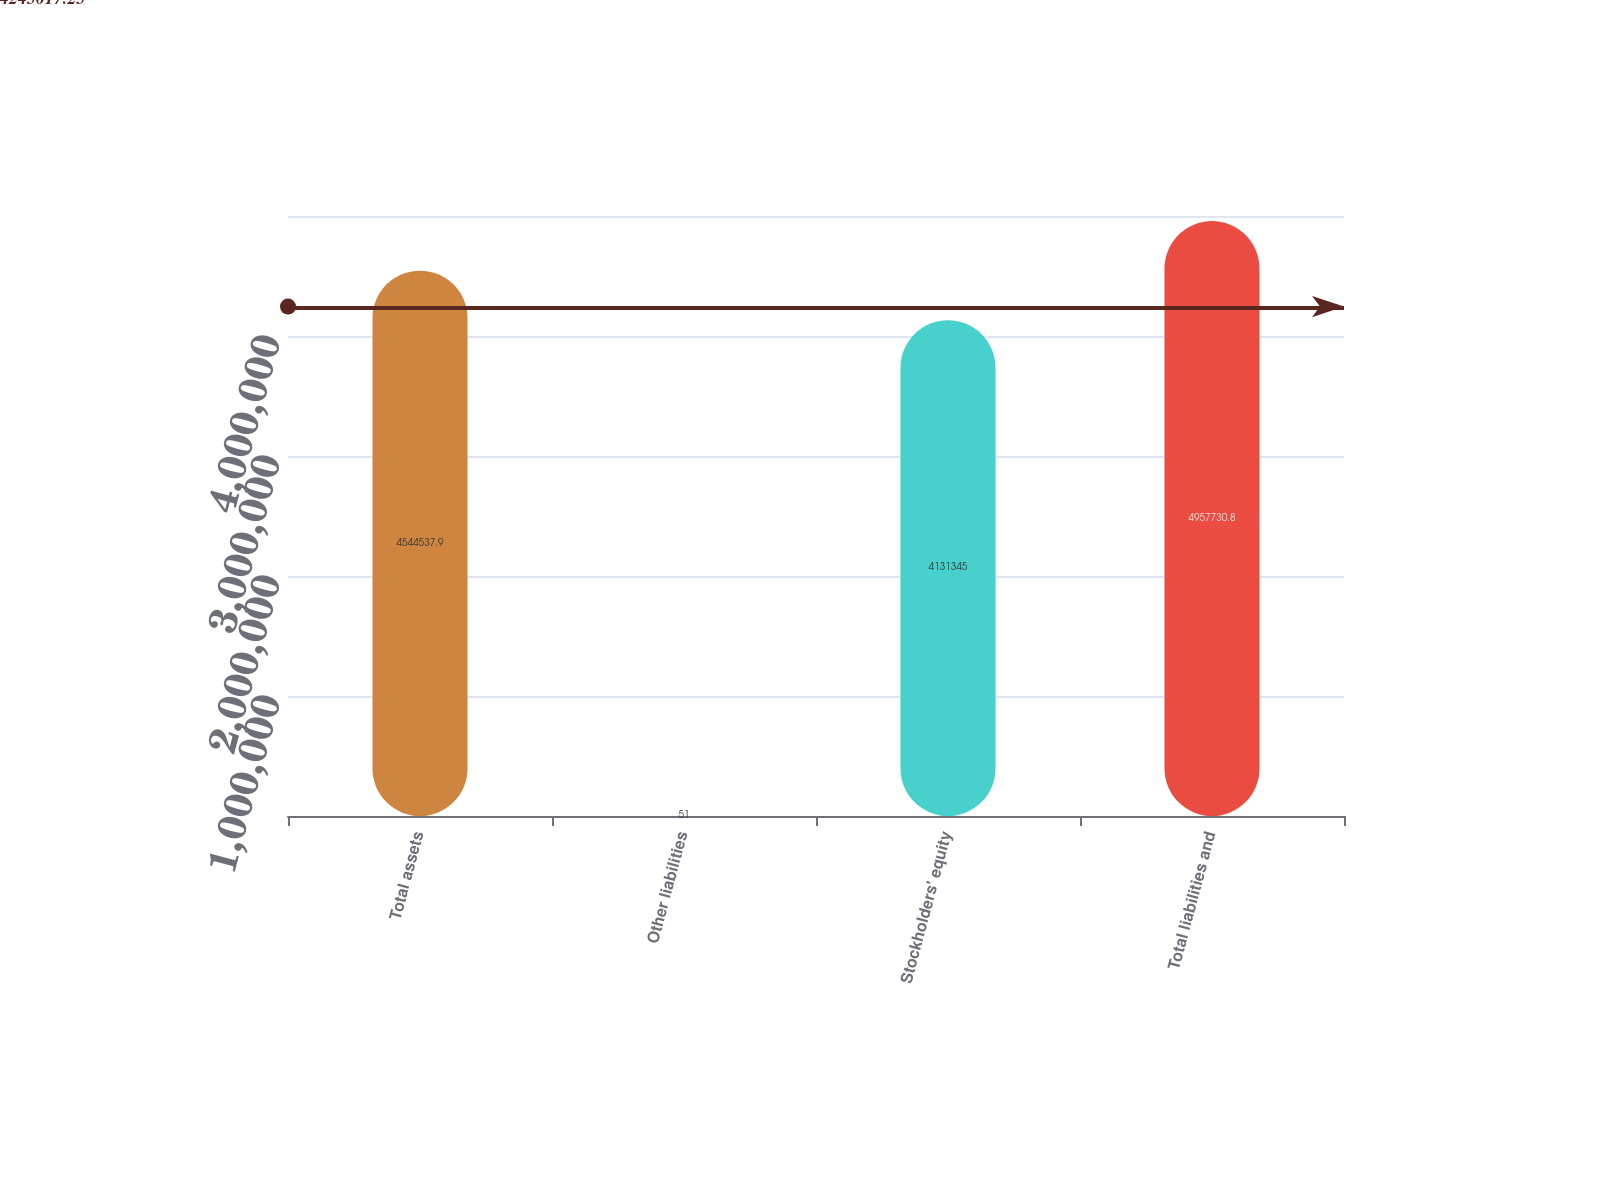<chart> <loc_0><loc_0><loc_500><loc_500><bar_chart><fcel>Total assets<fcel>Other liabilities<fcel>Stockholders' equity<fcel>Total liabilities and<nl><fcel>4.54454e+06<fcel>51<fcel>4.13134e+06<fcel>4.95773e+06<nl></chart> 